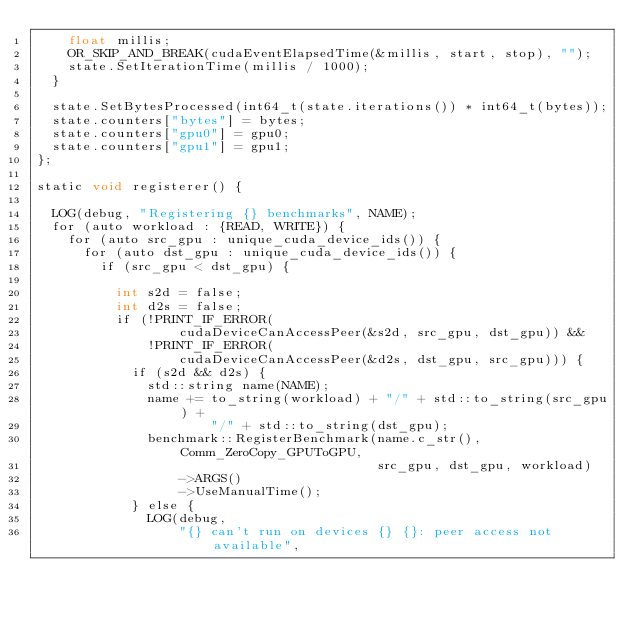Convert code to text. <code><loc_0><loc_0><loc_500><loc_500><_Cuda_>    float millis;
    OR_SKIP_AND_BREAK(cudaEventElapsedTime(&millis, start, stop), "");
    state.SetIterationTime(millis / 1000);
  }

  state.SetBytesProcessed(int64_t(state.iterations()) * int64_t(bytes));
  state.counters["bytes"] = bytes;
  state.counters["gpu0"] = gpu0;
  state.counters["gpu1"] = gpu1;
};

static void registerer() {

  LOG(debug, "Registering {} benchmarks", NAME);
  for (auto workload : {READ, WRITE}) {
    for (auto src_gpu : unique_cuda_device_ids()) {
      for (auto dst_gpu : unique_cuda_device_ids()) {
        if (src_gpu < dst_gpu) {

          int s2d = false;
          int d2s = false;
          if (!PRINT_IF_ERROR(
                  cudaDeviceCanAccessPeer(&s2d, src_gpu, dst_gpu)) &&
              !PRINT_IF_ERROR(
                  cudaDeviceCanAccessPeer(&d2s, dst_gpu, src_gpu))) {
            if (s2d && d2s) {
              std::string name(NAME);
              name += to_string(workload) + "/" + std::to_string(src_gpu) +
                      "/" + std::to_string(dst_gpu);
              benchmark::RegisterBenchmark(name.c_str(), Comm_ZeroCopy_GPUToGPU,
                                           src_gpu, dst_gpu, workload)
                  ->ARGS()
                  ->UseManualTime();
            } else {
              LOG(debug,
                  "{} can't run on devices {} {}: peer access not available",</code> 